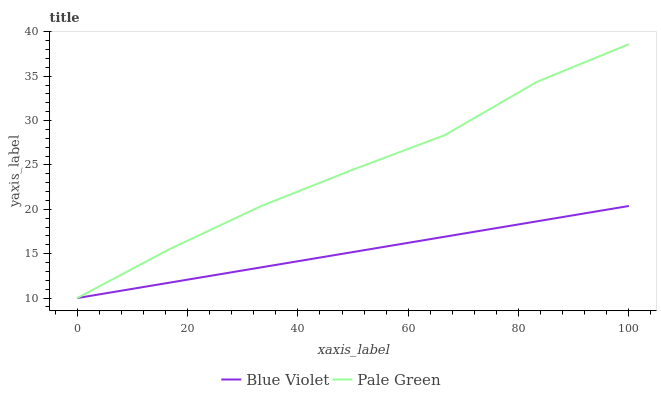Does Blue Violet have the minimum area under the curve?
Answer yes or no. Yes. Does Pale Green have the maximum area under the curve?
Answer yes or no. Yes. Does Blue Violet have the maximum area under the curve?
Answer yes or no. No. Is Blue Violet the smoothest?
Answer yes or no. Yes. Is Pale Green the roughest?
Answer yes or no. Yes. Is Blue Violet the roughest?
Answer yes or no. No. Does Pale Green have the lowest value?
Answer yes or no. Yes. Does Pale Green have the highest value?
Answer yes or no. Yes. Does Blue Violet have the highest value?
Answer yes or no. No. Does Pale Green intersect Blue Violet?
Answer yes or no. Yes. Is Pale Green less than Blue Violet?
Answer yes or no. No. Is Pale Green greater than Blue Violet?
Answer yes or no. No. 